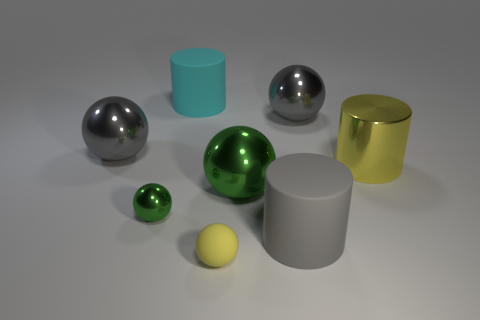Subtract all large green spheres. How many spheres are left? 4 Subtract all yellow balls. How many balls are left? 4 Subtract all red balls. Subtract all blue cylinders. How many balls are left? 5 Add 1 gray matte objects. How many objects exist? 9 Subtract all balls. How many objects are left? 3 Add 7 yellow metal things. How many yellow metal things are left? 8 Add 3 yellow things. How many yellow things exist? 5 Subtract 0 brown cylinders. How many objects are left? 8 Subtract all small yellow metal objects. Subtract all small objects. How many objects are left? 6 